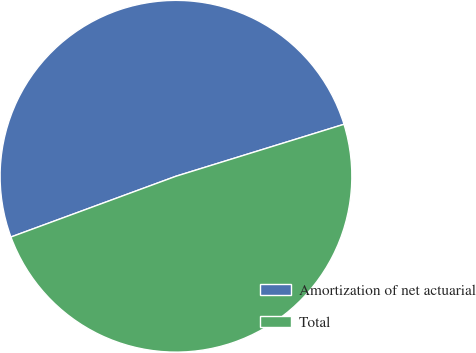<chart> <loc_0><loc_0><loc_500><loc_500><pie_chart><fcel>Amortization of net actuarial<fcel>Total<nl><fcel>50.84%<fcel>49.16%<nl></chart> 